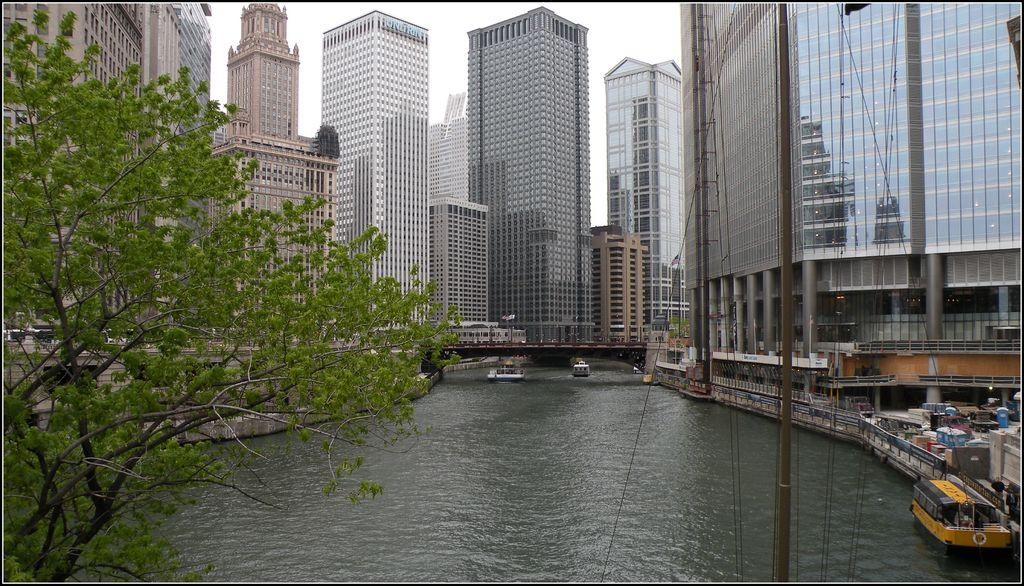What type of structures can be seen in the image? There are buildings in the image. What feature is common to many of the buildings? There are windows in the image. What can be seen on the water in the image? There are ships on the water in the image. What architectural feature connects the two sides of the water? There is a bridge in the image. What type of vegetation is present in the image? There are trees in the image. What is the color of the sky in the image? The sky appears to be white in color. What type of ink is used to write the names of the ships in the image? There is no writing or ink present in the image; it only shows ships on the water. What knowledge can be gained from the image about the history of the area? The image does not provide any historical context or information, so it cannot be used to gain knowledge about the history of the area. 